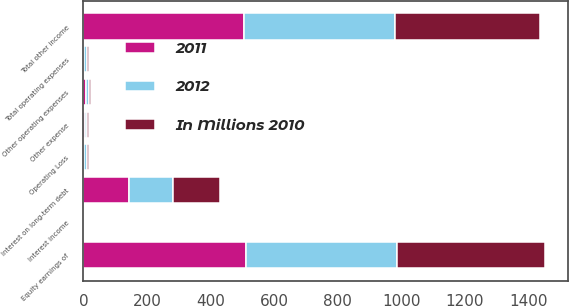Convert chart to OTSL. <chart><loc_0><loc_0><loc_500><loc_500><stacked_bar_chart><ecel><fcel>Other operating expenses<fcel>Total operating expenses<fcel>Operating Loss<fcel>Equity earnings of<fcel>Interest income<fcel>Other expense<fcel>Total other income<fcel>Interest on long-term debt<nl><fcel>2012<fcel>8<fcel>8<fcel>8<fcel>477<fcel>1<fcel>5<fcel>473<fcel>140<nl><fcel>2011<fcel>9<fcel>3<fcel>3<fcel>510<fcel>1<fcel>5<fcel>506<fcel>143<nl><fcel>In Millions 2010<fcel>6<fcel>6<fcel>6<fcel>464<fcel>1<fcel>8<fcel>457<fcel>147<nl></chart> 